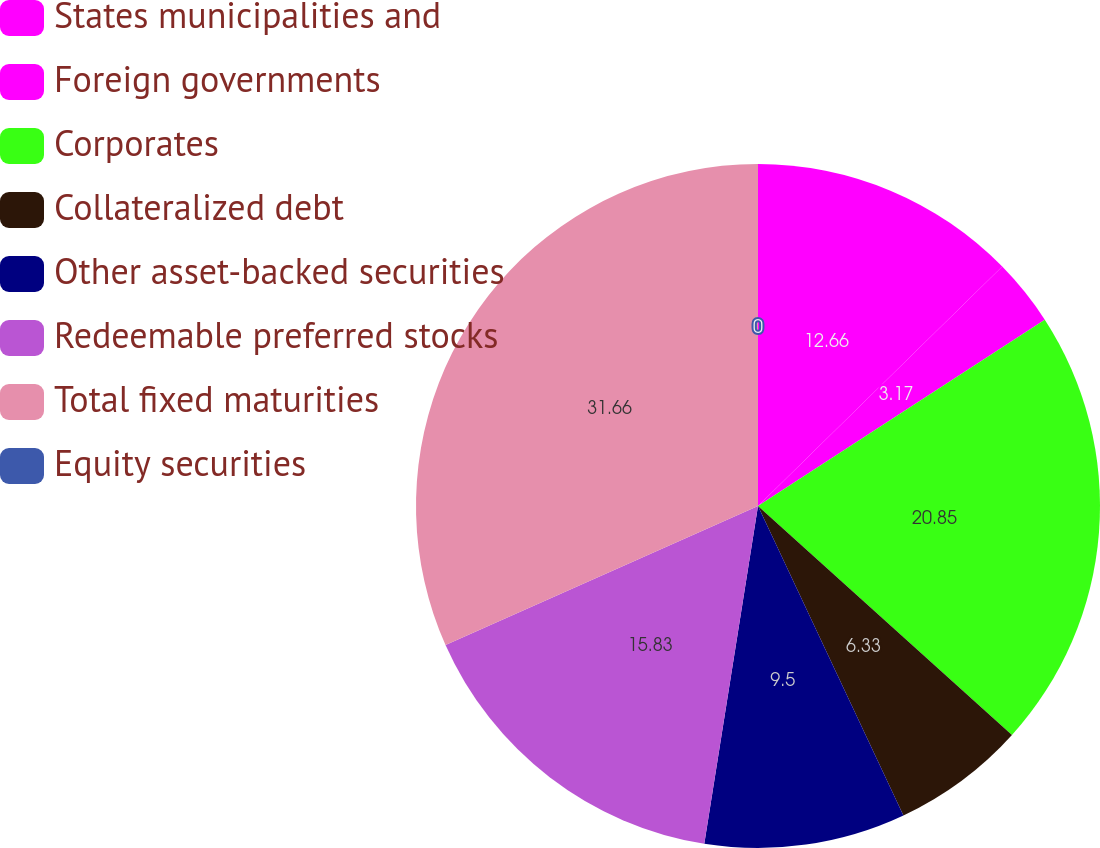<chart> <loc_0><loc_0><loc_500><loc_500><pie_chart><fcel>States municipalities and<fcel>Foreign governments<fcel>Corporates<fcel>Collateralized debt<fcel>Other asset-backed securities<fcel>Redeemable preferred stocks<fcel>Total fixed maturities<fcel>Equity securities<nl><fcel>12.66%<fcel>3.17%<fcel>20.85%<fcel>6.33%<fcel>9.5%<fcel>15.83%<fcel>31.66%<fcel>0.0%<nl></chart> 